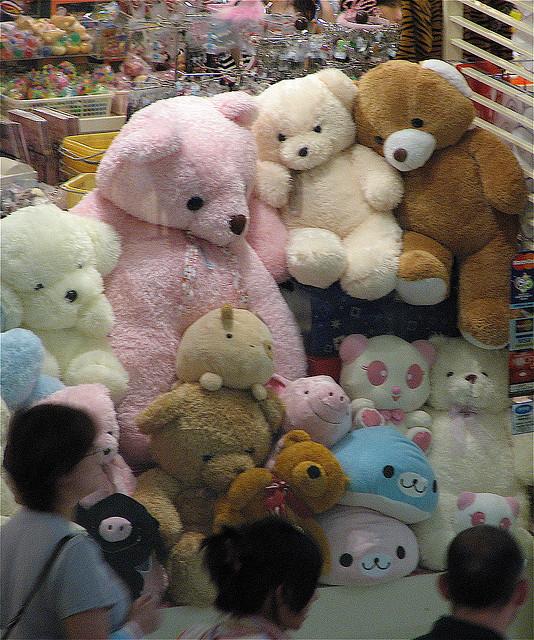How many of the stuffed animals are definitely female?
Give a very brief answer. 5. How many bears are there?
Answer briefly. 10. How many stuffed animals are there?
Short answer required. 16. What type of animals are these?
Quick response, please. Stuffed. Are these located in a store?
Short answer required. Yes. 